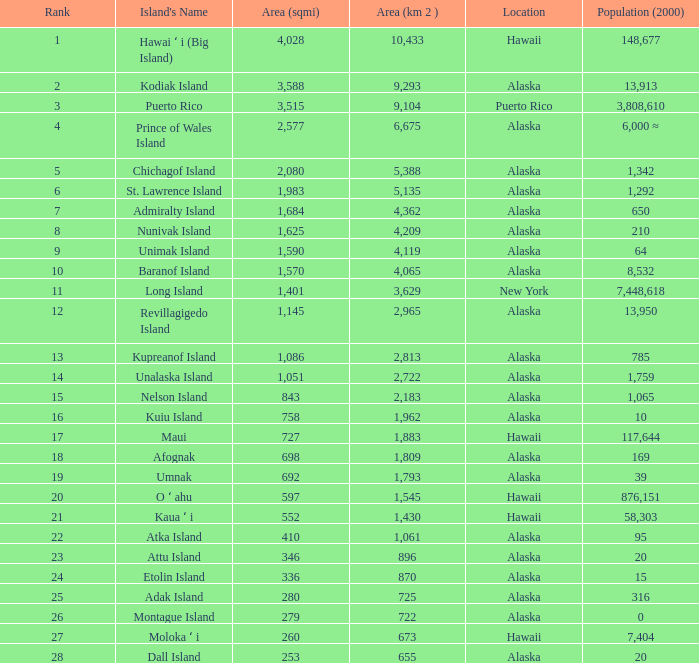What is the largest area in Alaska with a population of 39 and rank over 19? None. 